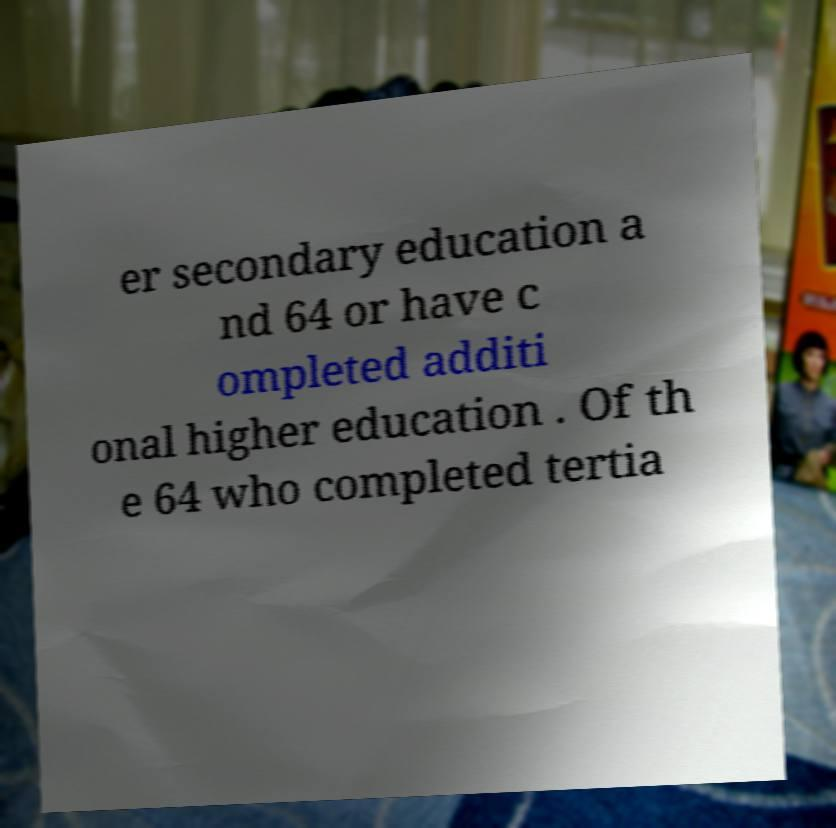Can you read and provide the text displayed in the image?This photo seems to have some interesting text. Can you extract and type it out for me? er secondary education a nd 64 or have c ompleted additi onal higher education . Of th e 64 who completed tertia 